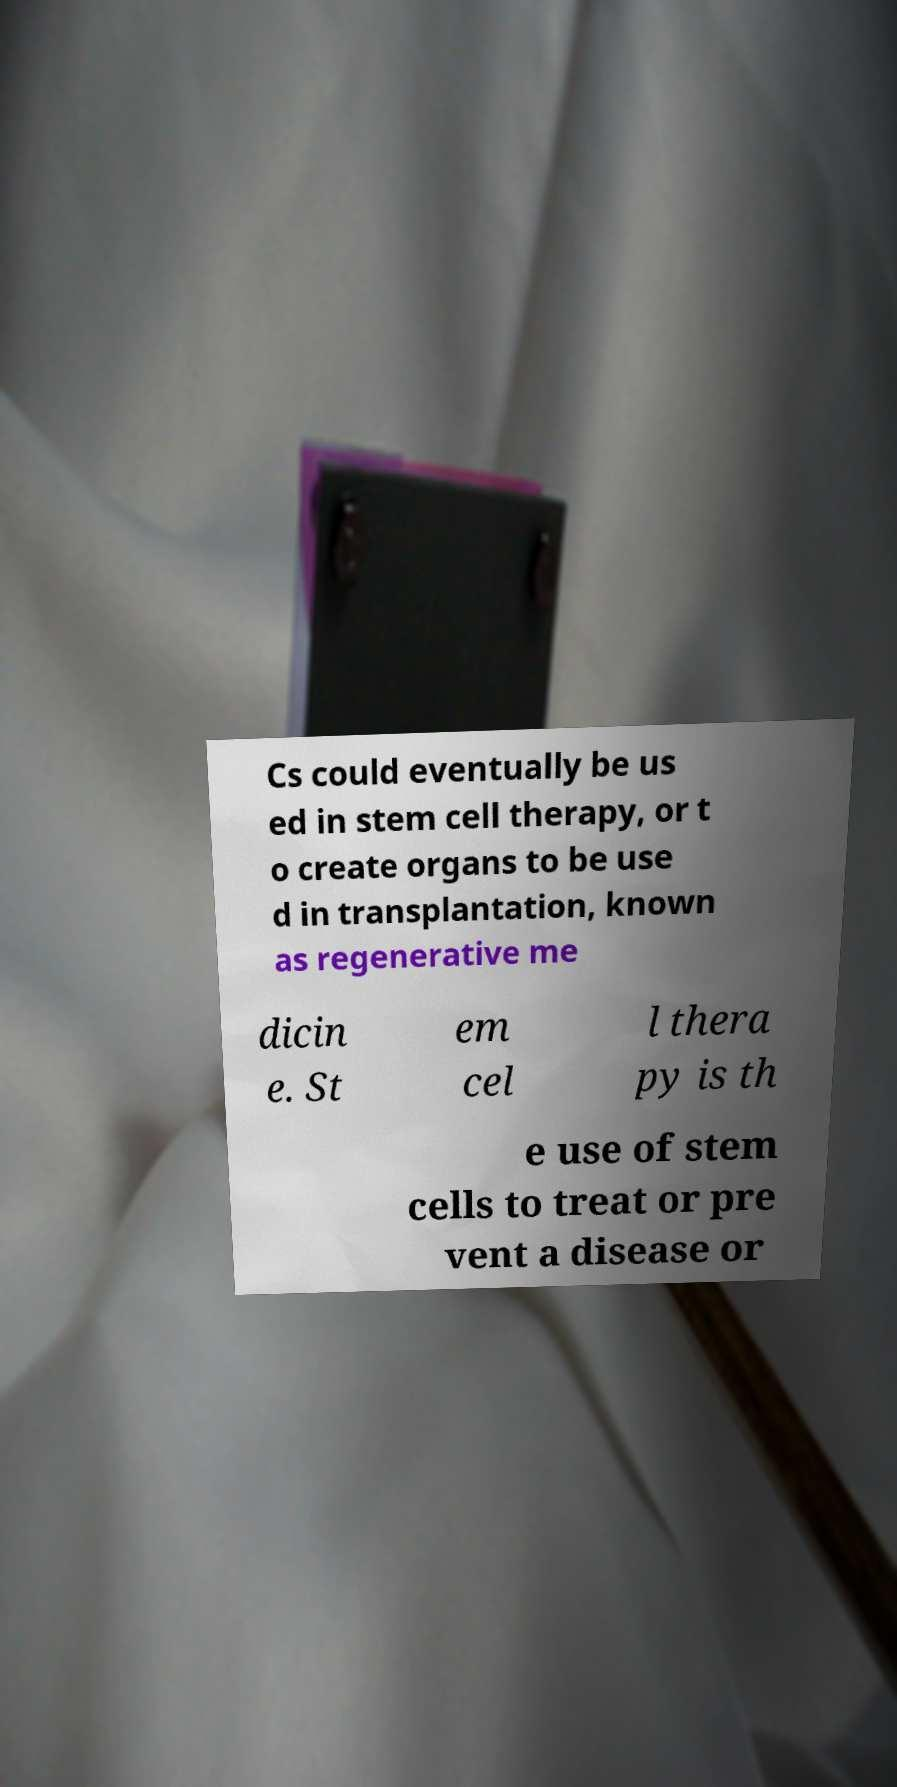There's text embedded in this image that I need extracted. Can you transcribe it verbatim? Cs could eventually be us ed in stem cell therapy, or t o create organs to be use d in transplantation, known as regenerative me dicin e. St em cel l thera py is th e use of stem cells to treat or pre vent a disease or 